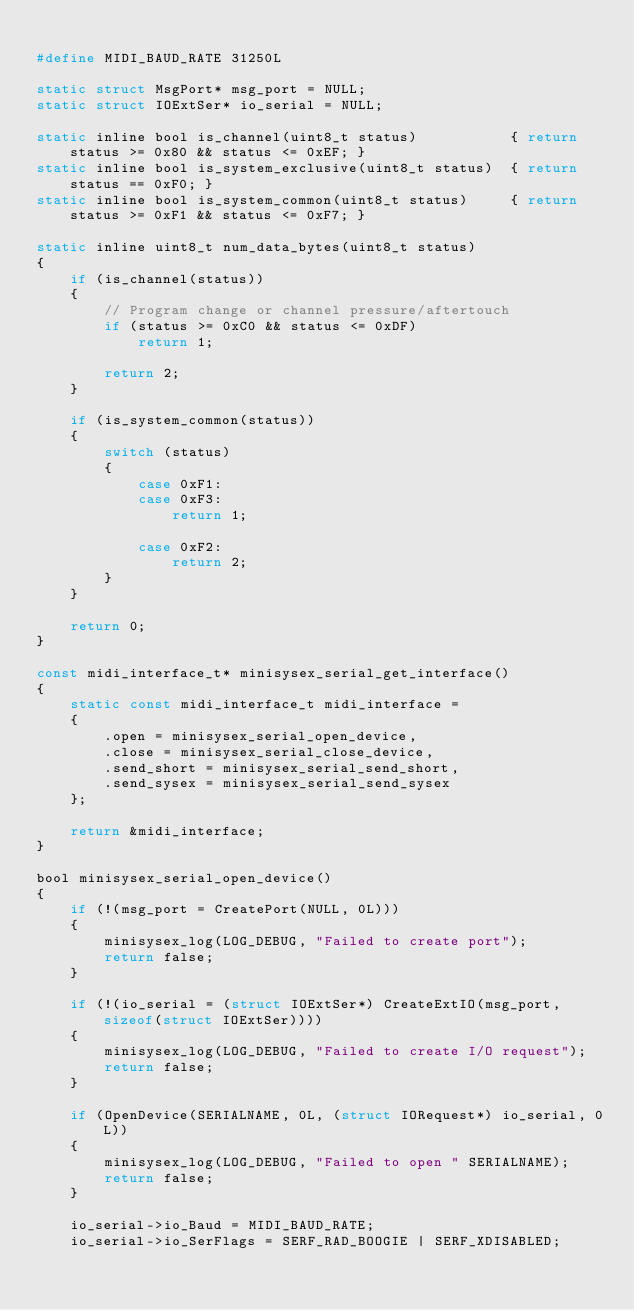<code> <loc_0><loc_0><loc_500><loc_500><_C_>
#define MIDI_BAUD_RATE 31250L

static struct MsgPort* msg_port = NULL;
static struct IOExtSer* io_serial = NULL;

static inline bool is_channel(uint8_t status)			{ return status >= 0x80 && status <= 0xEF; }
static inline bool is_system_exclusive(uint8_t status) 	{ return status == 0xF0; }
static inline bool is_system_common(uint8_t status)		{ return status >= 0xF1 && status <= 0xF7; }

static inline uint8_t num_data_bytes(uint8_t status)
{
	if (is_channel(status))
	{
		// Program change or channel pressure/aftertouch
		if (status >= 0xC0 && status <= 0xDF)
			return 1;

		return 2;
	}

	if (is_system_common(status))
	{
		switch (status)
		{
			case 0xF1:
			case 0xF3:
				return 1;

			case 0xF2:
				return 2;
		}
	}

	return 0;
}

const midi_interface_t* minisysex_serial_get_interface()
{
	static const midi_interface_t midi_interface =
	{
		.open = minisysex_serial_open_device,
		.close = minisysex_serial_close_device,
		.send_short = minisysex_serial_send_short,
		.send_sysex = minisysex_serial_send_sysex
	};

	return &midi_interface;
}

bool minisysex_serial_open_device()
{
	if (!(msg_port = CreatePort(NULL, 0L)))
	{
		minisysex_log(LOG_DEBUG, "Failed to create port");
		return false;
	}

	if (!(io_serial = (struct IOExtSer*) CreateExtIO(msg_port, sizeof(struct IOExtSer))))
	{
		minisysex_log(LOG_DEBUG, "Failed to create I/O request");
		return false;
	}

	if (OpenDevice(SERIALNAME, 0L, (struct IORequest*) io_serial, 0L))
	{
		minisysex_log(LOG_DEBUG, "Failed to open " SERIALNAME);
		return false;
	}

	io_serial->io_Baud = MIDI_BAUD_RATE;
	io_serial->io_SerFlags = SERF_RAD_BOOGIE | SERF_XDISABLED;</code> 